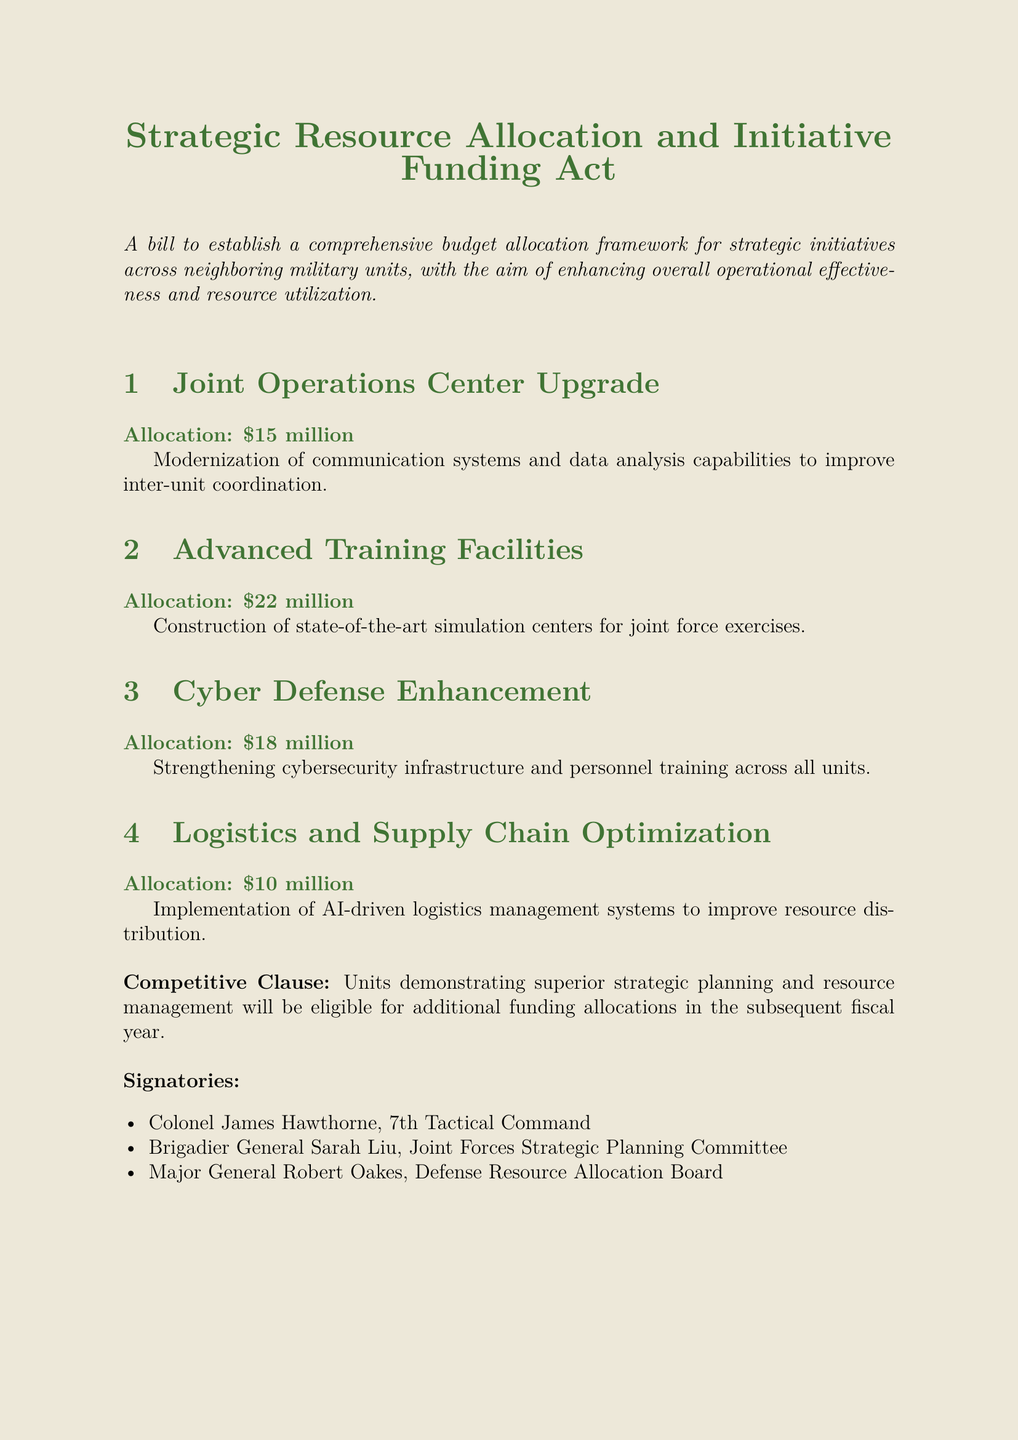What is the total budget allocation proposed in the bill? The total budget allocation is the sum of all allocations listed in the bill: $15 million + $22 million + $18 million + $10 million = $65 million.
Answer: $65 million Who signed the bill? The signatories of the bill are listed at the end and include Colonel James Hawthorne, Brigadier General Sarah Liu, and Major General Robert Oakes.
Answer: Colonel James Hawthorne, Brigadier General Sarah Liu, Major General Robert Oakes How much is allocated for Cyber Defense Enhancement? The Cyber Defense Enhancement section specifies an allocation of $18 million, which is stated in bold and highlighted.
Answer: $18 million What is the purpose of the Joint Operations Center Upgrade? The purpose of this initiative is stated as modernizing communication systems and improving inter-unit coordination.
Answer: Improve inter-unit coordination What additional funding is mentioned in the Competitive Clause? The Competitive Clause indicates that units demonstrating superior strategic planning are eligible for additional funding.
Answer: Additional funding What type of facilities are being constructed according to the bill? The bill mentions the construction of state-of-the-art simulation centers for advanced training purposes.
Answer: Simulation centers How much funding is designated for Logistics and Supply Chain Optimization? The budget for Logistics and Supply Chain Optimization is specified as $10 million in the respective section.
Answer: $10 million Which initiative has the highest budget allocation? Among the listed initiatives, Advanced Training Facilities has the highest budget allocation of $22 million.
Answer: Advanced Training Facilities What technology is mentioned for Logistics and Supply Chain Optimization? The bill specifies the implementation of AI-driven logistics management systems for this initiative.
Answer: AI-driven logistics management systems 